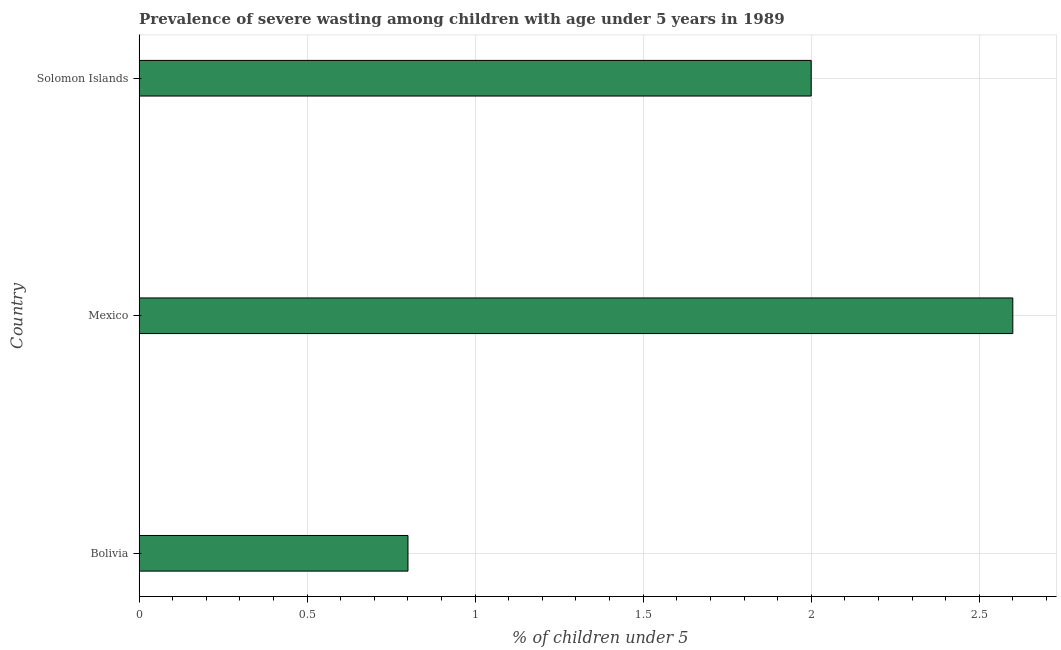Does the graph contain any zero values?
Ensure brevity in your answer.  No. Does the graph contain grids?
Provide a succinct answer. Yes. What is the title of the graph?
Keep it short and to the point. Prevalence of severe wasting among children with age under 5 years in 1989. What is the label or title of the X-axis?
Make the answer very short.  % of children under 5. What is the label or title of the Y-axis?
Offer a terse response. Country. What is the prevalence of severe wasting in Mexico?
Make the answer very short. 2.6. Across all countries, what is the maximum prevalence of severe wasting?
Your answer should be compact. 2.6. Across all countries, what is the minimum prevalence of severe wasting?
Your response must be concise. 0.8. In which country was the prevalence of severe wasting maximum?
Offer a terse response. Mexico. What is the sum of the prevalence of severe wasting?
Provide a short and direct response. 5.4. What is the average prevalence of severe wasting per country?
Your answer should be very brief. 1.8. What is the median prevalence of severe wasting?
Your response must be concise. 2. What is the ratio of the prevalence of severe wasting in Bolivia to that in Solomon Islands?
Offer a very short reply. 0.4. Is the prevalence of severe wasting in Bolivia less than that in Mexico?
Ensure brevity in your answer.  Yes. Is the difference between the prevalence of severe wasting in Bolivia and Solomon Islands greater than the difference between any two countries?
Your response must be concise. No. Are all the bars in the graph horizontal?
Make the answer very short. Yes. Are the values on the major ticks of X-axis written in scientific E-notation?
Make the answer very short. No. What is the  % of children under 5 in Bolivia?
Ensure brevity in your answer.  0.8. What is the  % of children under 5 in Mexico?
Provide a short and direct response. 2.6. What is the ratio of the  % of children under 5 in Bolivia to that in Mexico?
Keep it short and to the point. 0.31. What is the ratio of the  % of children under 5 in Mexico to that in Solomon Islands?
Give a very brief answer. 1.3. 